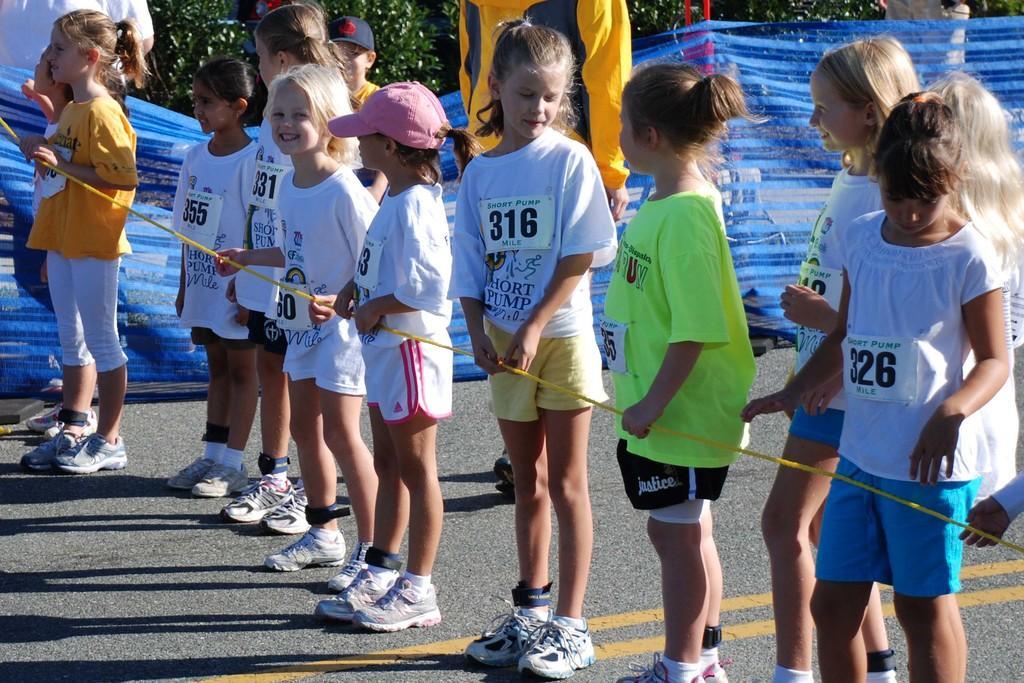Can you describe this image briefly? In this picture we can see some small girls wearing white t-shirt standing in the front and holding the rope. Behind we can see the blue color fencing net and some trees. 